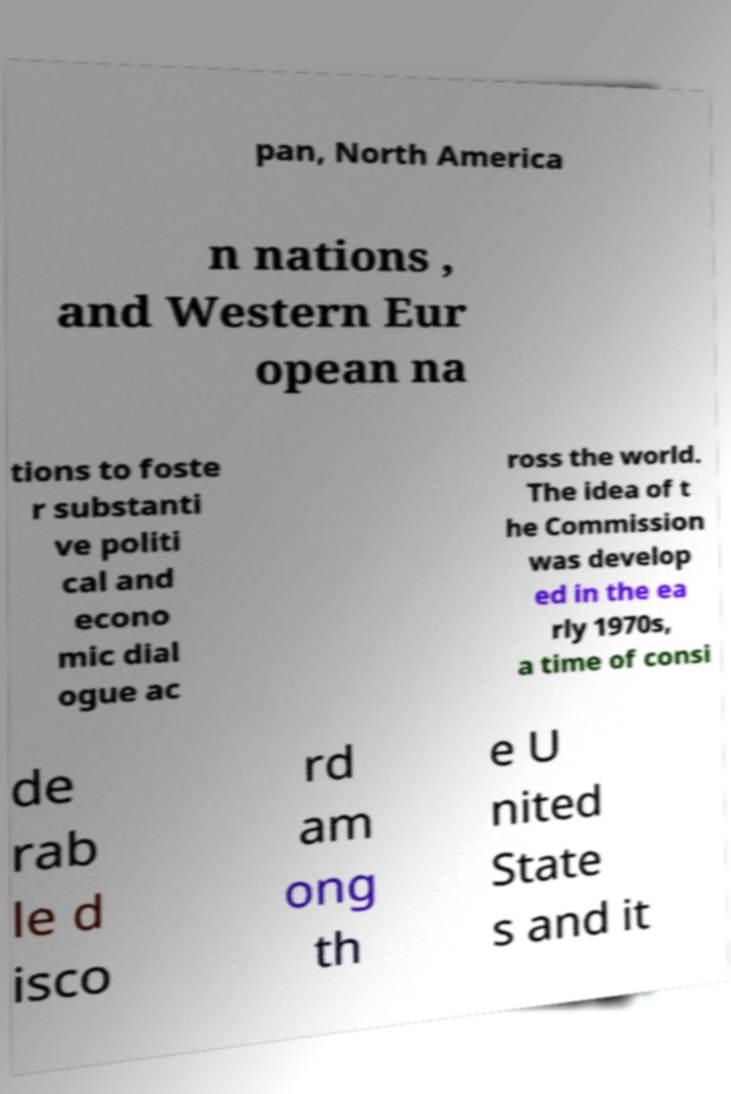Can you read and provide the text displayed in the image?This photo seems to have some interesting text. Can you extract and type it out for me? pan, North America n nations , and Western Eur opean na tions to foste r substanti ve politi cal and econo mic dial ogue ac ross the world. The idea of t he Commission was develop ed in the ea rly 1970s, a time of consi de rab le d isco rd am ong th e U nited State s and it 